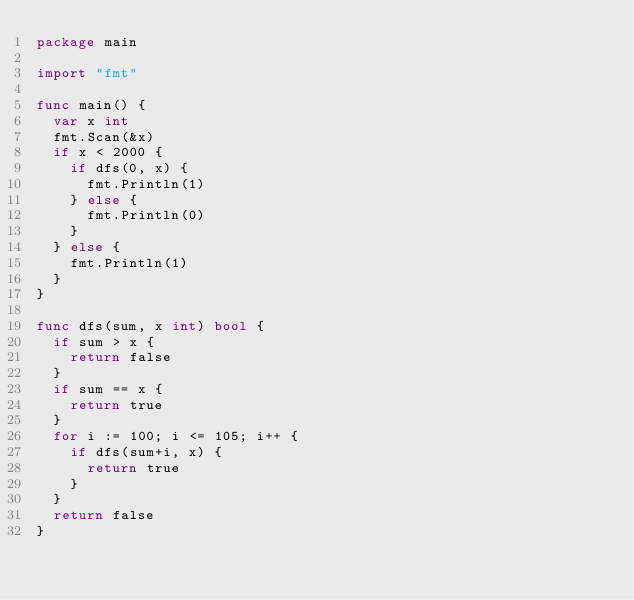<code> <loc_0><loc_0><loc_500><loc_500><_Go_>package main

import "fmt"

func main() {
	var x int
	fmt.Scan(&x)
	if x < 2000 {
		if dfs(0, x) {
			fmt.Println(1)
		} else {
			fmt.Println(0)
		}
	} else {
		fmt.Println(1)
	}
}

func dfs(sum, x int) bool {
	if sum > x {
		return false
	}
	if sum == x {
		return true
	}
	for i := 100; i <= 105; i++ {
		if dfs(sum+i, x) {
			return true
		}
	}
	return false
}
</code> 